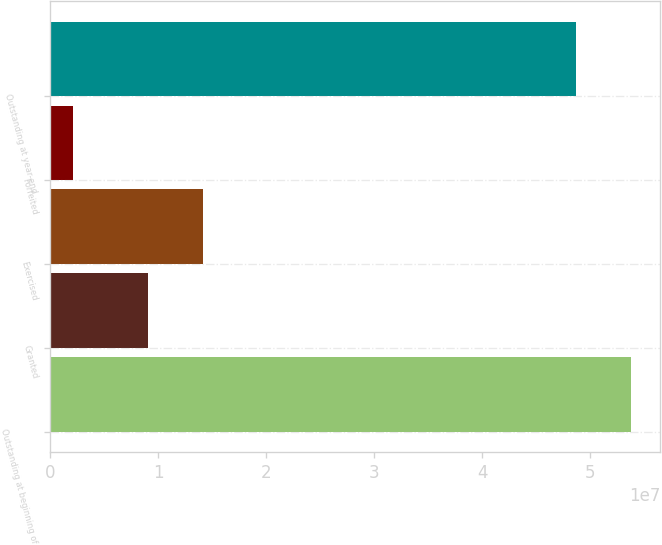Convert chart to OTSL. <chart><loc_0><loc_0><loc_500><loc_500><bar_chart><fcel>Outstanding at beginning of<fcel>Granted<fcel>Exercised<fcel>Forfeited<fcel>Outstanding at year-end<nl><fcel>5.37686e+07<fcel>9.05514e+06<fcel>1.41452e+07<fcel>2.07834e+06<fcel>4.86786e+07<nl></chart> 